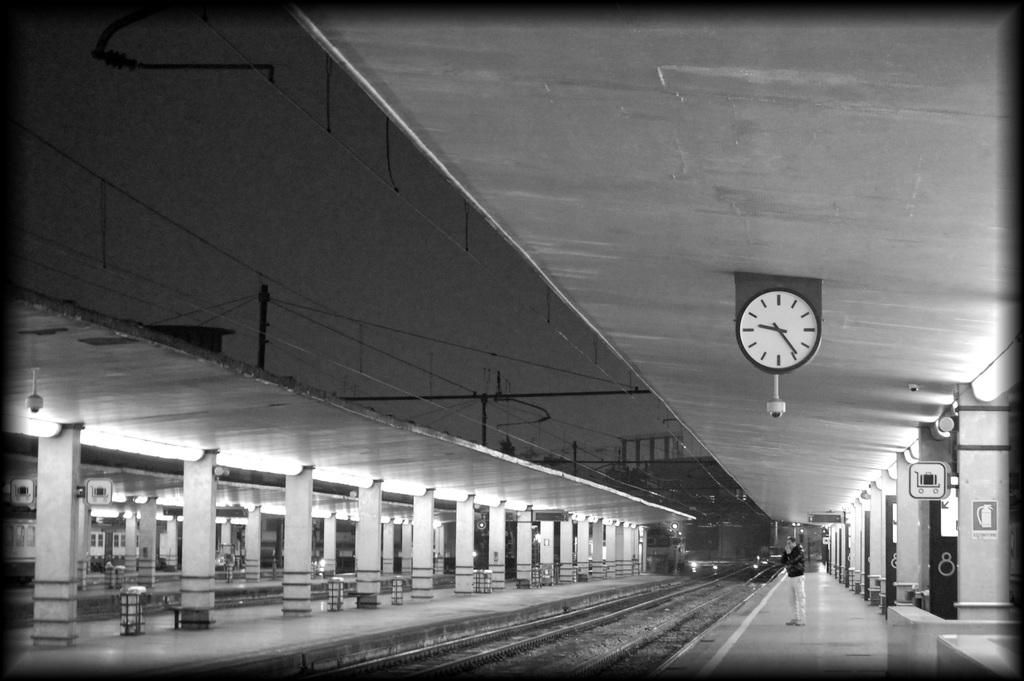What can be seen running through the image? There are railway tracks in the image. What is the person in the image doing? There is a person standing in front of the railway tracks. What time-related object is present in the image? There is a clock attached to a wall in the image. What type of illumination is visible in the image? There are lights visible in the image. What color scheme is used in the image? The image is in black and white. What type of vest is the dad wearing in the image? There is no dad or vest present in the image. What kind of cake is being served at the railway tracks in the image? There is no cake present in the image; it features railway tracks, a person, a clock, lights, and a black and white color scheme. 